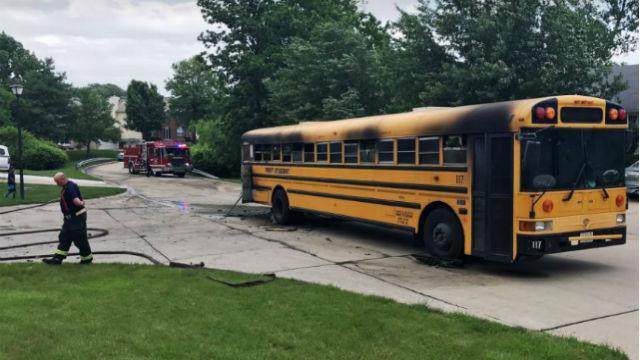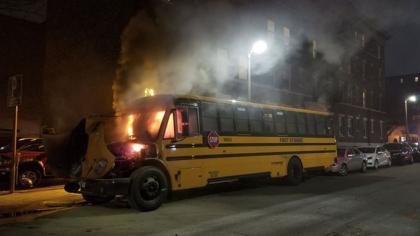The first image is the image on the left, the second image is the image on the right. Examine the images to the left and right. Is the description "In at least one image, a fire is blazing at the front of a bus parked with its red stop sign facing the camera." accurate? Answer yes or no. Yes. The first image is the image on the left, the second image is the image on the right. For the images shown, is this caption "At least one of the schoolbusses is on fire." true? Answer yes or no. Yes. 